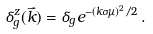Convert formula to latex. <formula><loc_0><loc_0><loc_500><loc_500>\delta _ { g } ^ { z } ( \vec { k } ) = \delta _ { g } e ^ { - ( k \sigma \mu ) ^ { 2 } / 2 } \, .</formula> 